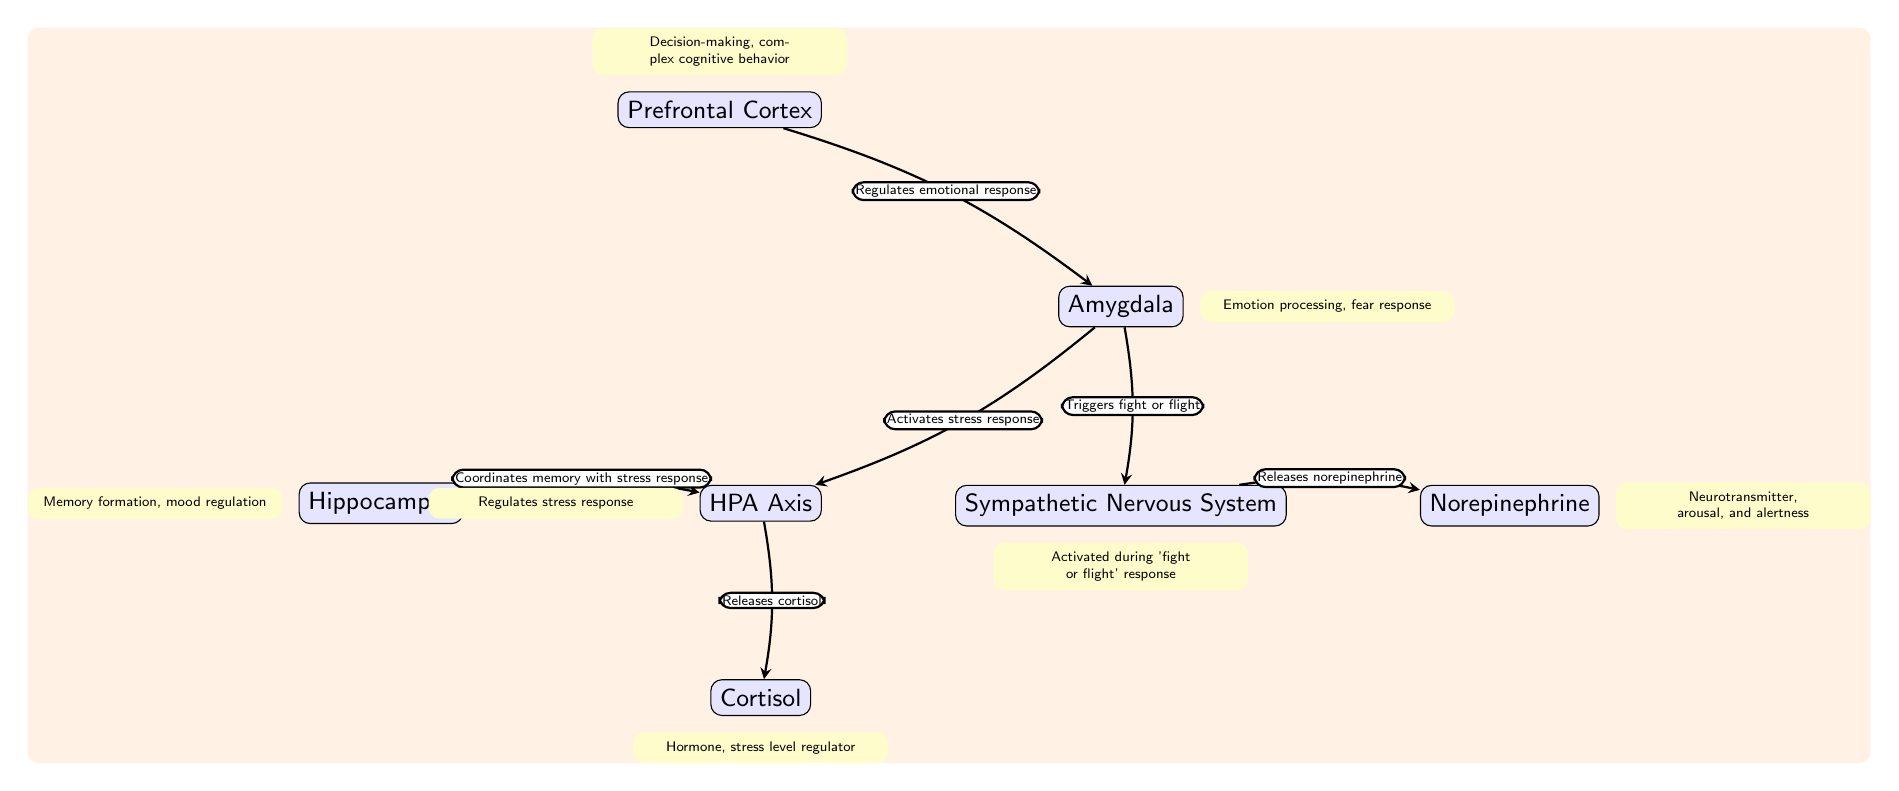What is the function of the Prefrontal Cortex? The diagram indicates that the Prefrontal Cortex regulates emotional responses and is involved in decision-making and complex cognitive behavior.
Answer: Regulates emotional response Which neurotransmitter is released by the Sympathetic Nervous System? The diagram shows that the Sympathetic Nervous System triggers the release of norepinephrine.
Answer: Norepinephrine How many main nodes are present in the diagram? Counting the nodes in the diagram, there are a total of six main nodes representing different brain regions and systems involved in the response to stress.
Answer: Six What role does the Hippocampus play in relation to the HPA Axis? The diagram illustrates that the Hippocampus coordinates memory with the stress response directed by the HPA Axis.
Answer: Coordinates memory with stress response Which brain region activates the stress response? The diagram indicates that the Amygdala activates the stress response by communicating with the HPA Axis.
Answer: Amygdala Explain the connection between the Amygdala and the Sympathetic Nervous System. The diagram shows an edge from the Amygdala to the Sympathetic Nervous System, indicating that the Amygdala triggers the fight or flight response. This suggests that emotional processing by the Amygdala leads to physical stress responses managed by the Sympathetic Nervous System.
Answer: Triggers fight or flight What hormone is released by the HPA Axis? According to the diagram, the HPA Axis releases cortisol.
Answer: Cortisol What does the Amygdala process according to the diagram? The diagram specifies that the Amygdala processes emotions, particularly regarding the fear response.
Answer: Emotion processing, fear response 